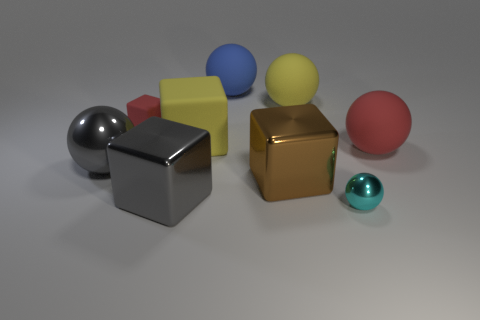Subtract all small shiny balls. How many balls are left? 4 Add 1 balls. How many objects exist? 10 Subtract all red blocks. How many blocks are left? 3 Subtract 3 balls. How many balls are left? 2 Subtract all cubes. How many objects are left? 5 Subtract all purple balls. Subtract all red blocks. How many balls are left? 5 Subtract all big gray things. Subtract all yellow matte balls. How many objects are left? 6 Add 2 tiny cyan metal objects. How many tiny cyan metal objects are left? 3 Add 6 tiny red metal things. How many tiny red metal things exist? 6 Subtract 1 red spheres. How many objects are left? 8 